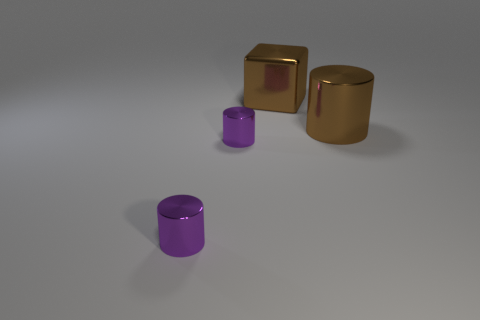Does the shiny block have the same color as the large cylinder?
Provide a short and direct response. Yes. Is the color of the big cube the same as the metallic thing to the right of the big cube?
Offer a very short reply. Yes. Is the number of metal blocks to the left of the big metallic cylinder greater than the number of big objects?
Your answer should be very brief. No. What number of things are either big brown objects right of the large brown metal cube or large things to the right of the large cube?
Make the answer very short. 1. What size is the metal thing that is the same color as the metal cube?
Offer a terse response. Large. What number of red things are small cylinders or balls?
Your response must be concise. 0. Are there any big blocks on the left side of the metallic cube?
Keep it short and to the point. No. There is a metallic thing behind the shiny cylinder that is to the right of the shiny block; what size is it?
Ensure brevity in your answer.  Large. What number of big things have the same color as the metallic cube?
Your answer should be very brief. 1. What size is the brown shiny cylinder?
Provide a short and direct response. Large. 